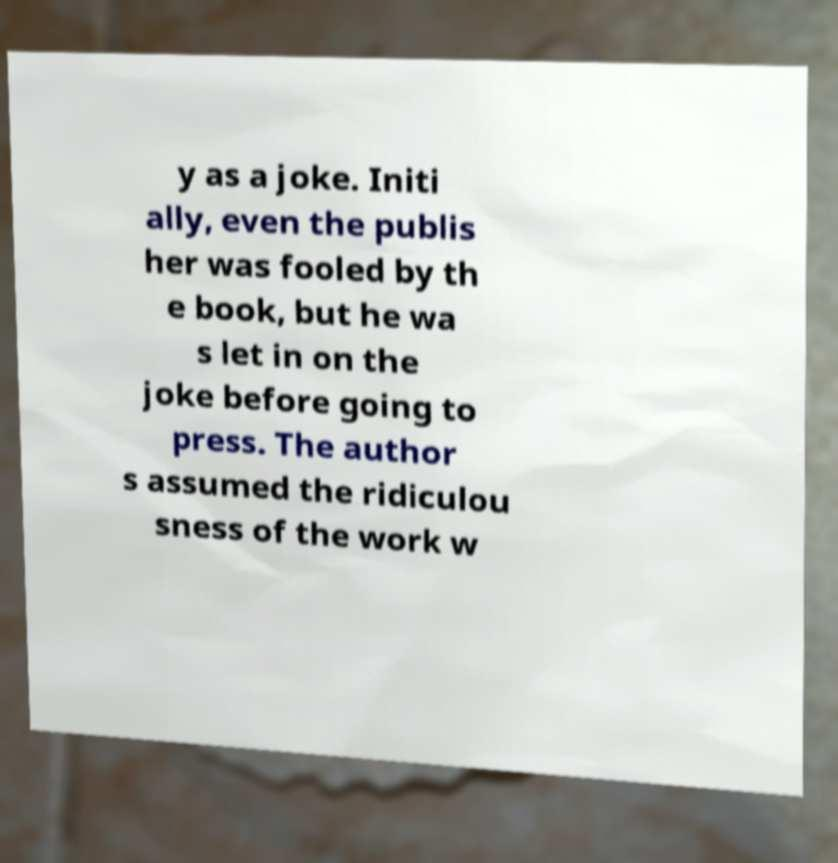What messages or text are displayed in this image? I need them in a readable, typed format. y as a joke. Initi ally, even the publis her was fooled by th e book, but he wa s let in on the joke before going to press. The author s assumed the ridiculou sness of the work w 